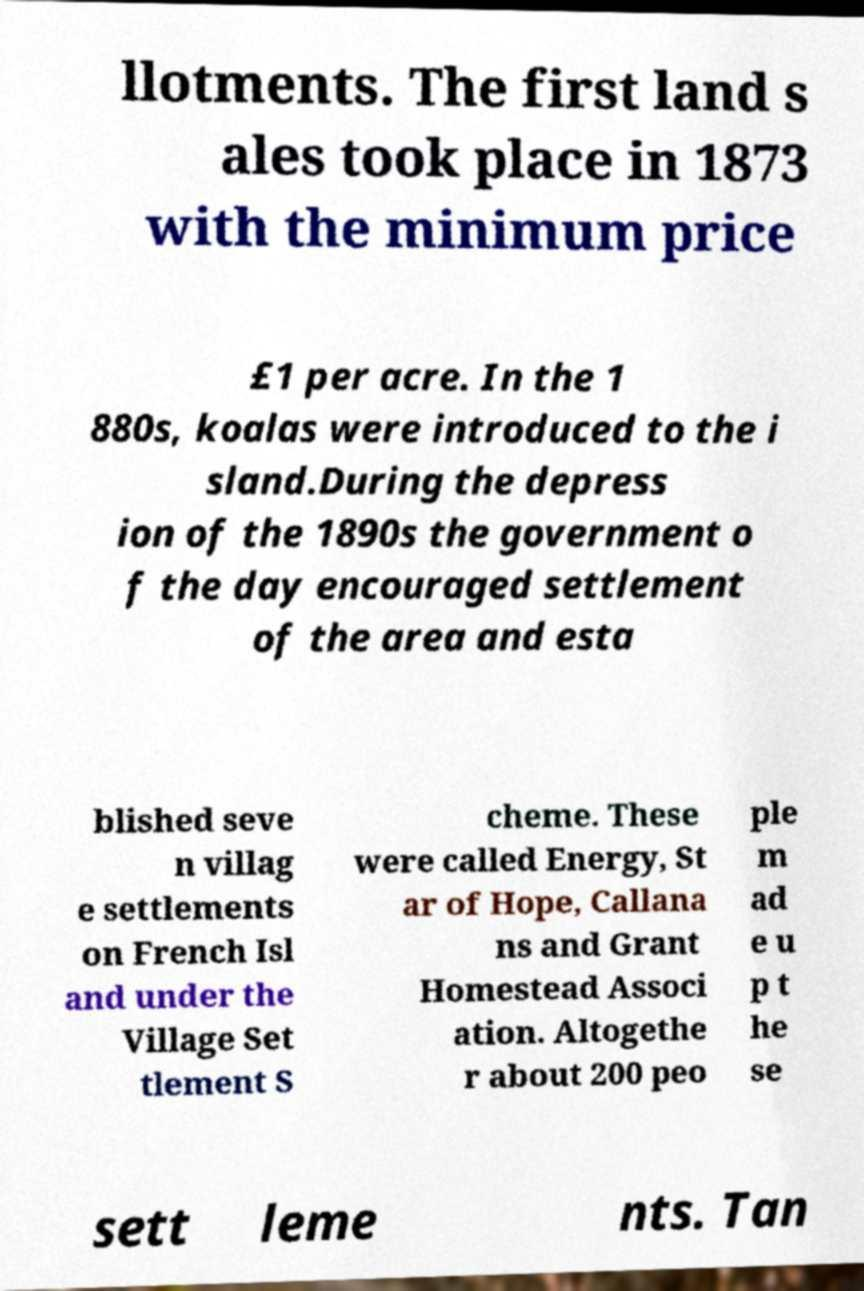What messages or text are displayed in this image? I need them in a readable, typed format. llotments. The first land s ales took place in 1873 with the minimum price £1 per acre. In the 1 880s, koalas were introduced to the i sland.During the depress ion of the 1890s the government o f the day encouraged settlement of the area and esta blished seve n villag e settlements on French Isl and under the Village Set tlement S cheme. These were called Energy, St ar of Hope, Callana ns and Grant Homestead Associ ation. Altogethe r about 200 peo ple m ad e u p t he se sett leme nts. Tan 